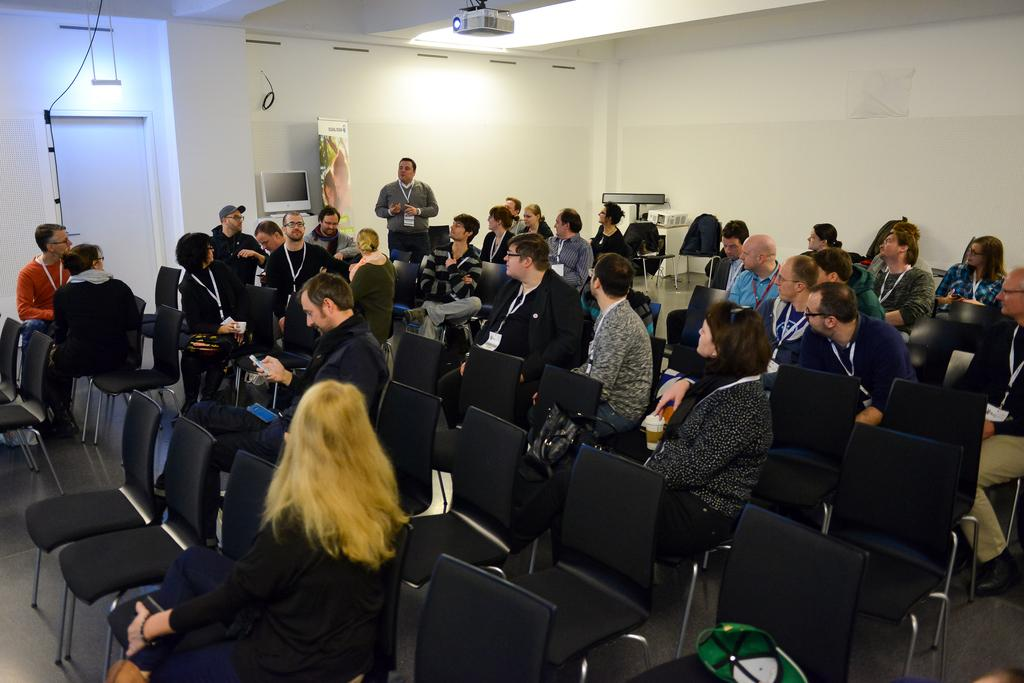How many people are in the image? There is a group of people in the image. What are the people in the image doing? Some people are sitting, while others are standing. What can be seen on the wall in the image? There is a white color wall in the image. What device is present in the image? A projector is present in the image. What architectural feature is visible in the image? There is a door in the image. What type of jail can be seen in the image? There is no jail present in the image. How does the taste of the air in the image compare to the taste of the air outside? The image does not provide any information about the taste of the air, as taste is a sensory experience that cannot be conveyed through visuals. 